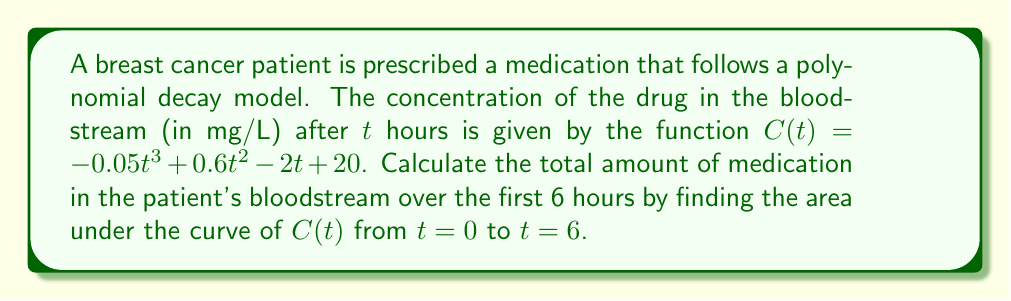Give your solution to this math problem. To find the total amount of medication in the bloodstream over time, we need to calculate the definite integral of the concentration function $C(t)$ from $t=0$ to $t=6$. 

1) The given function is $C(t) = -0.05t^3 + 0.6t^2 - 2t + 20$

2) To integrate, we increase each term's exponent by 1 and divide by the new exponent:

   $$\int C(t) dt = -0.05\frac{t^4}{4} + 0.6\frac{t^3}{3} - 2\frac{t^2}{2} + 20t + K$$

3) Evaluate the definite integral from $t=0$ to $t=6$:

   $$\int_0^6 C(t) dt = [-0.05\frac{t^4}{4} + 0.6\frac{t^3}{3} - t^2 + 20t]_0^6$$

4) Substitute $t=6$ and $t=0$:

   $$= (-0.05\frac{6^4}{4} + 0.6\frac{6^3}{3} - 6^2 + 20(6)) - (-0.05\frac{0^4}{4} + 0.6\frac{0^3}{3} - 0^2 + 20(0))$$

5) Simplify:

   $$= (-27 + 43.2 - 36 + 120) - (0)$$
   $$= 100.2$$

Therefore, the total amount of medication in the patient's bloodstream over the first 6 hours is 100.2 mg⋅L⁻¹⋅h.
Answer: 100.2 mg⋅L⁻¹⋅h 